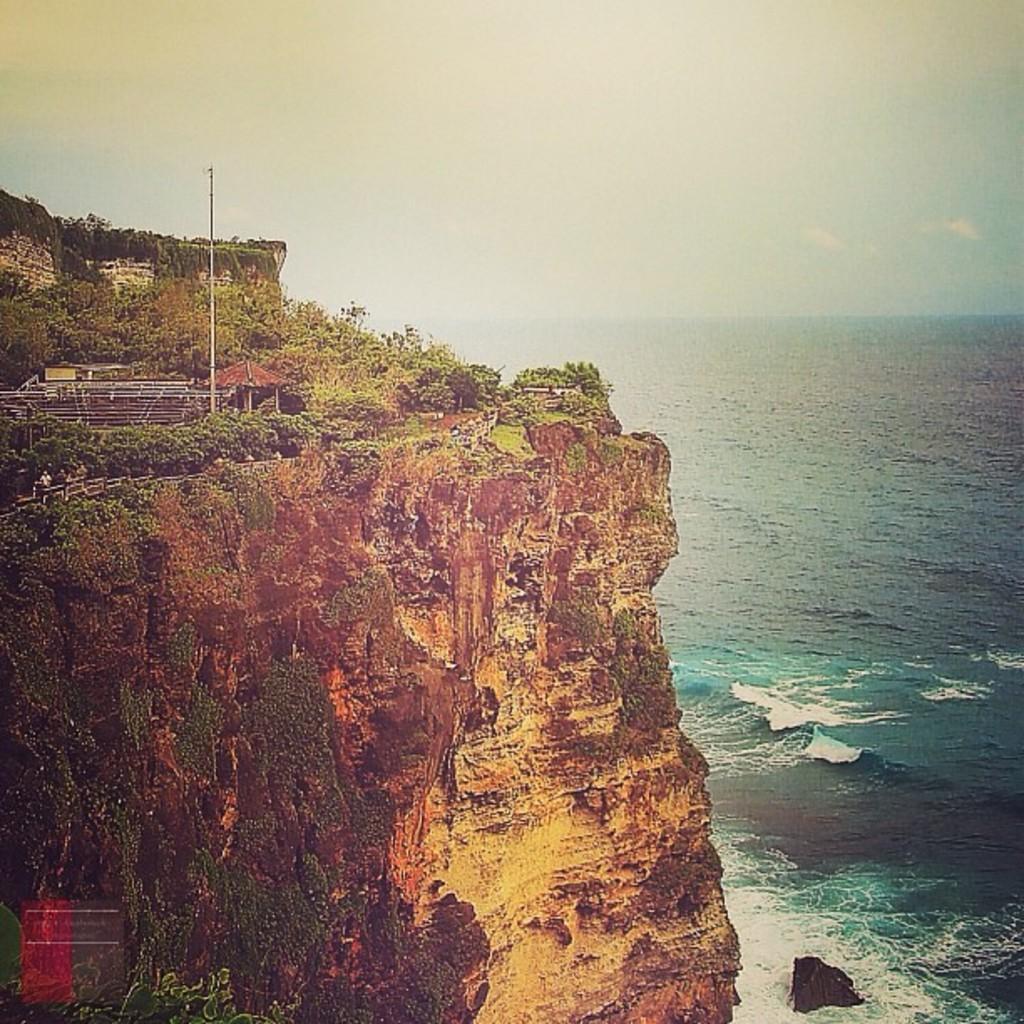In one or two sentences, can you explain what this image depicts? There is a mountain on the left side of this image, and there is a sea on the right side of this image. The sky is at the top of this image. 